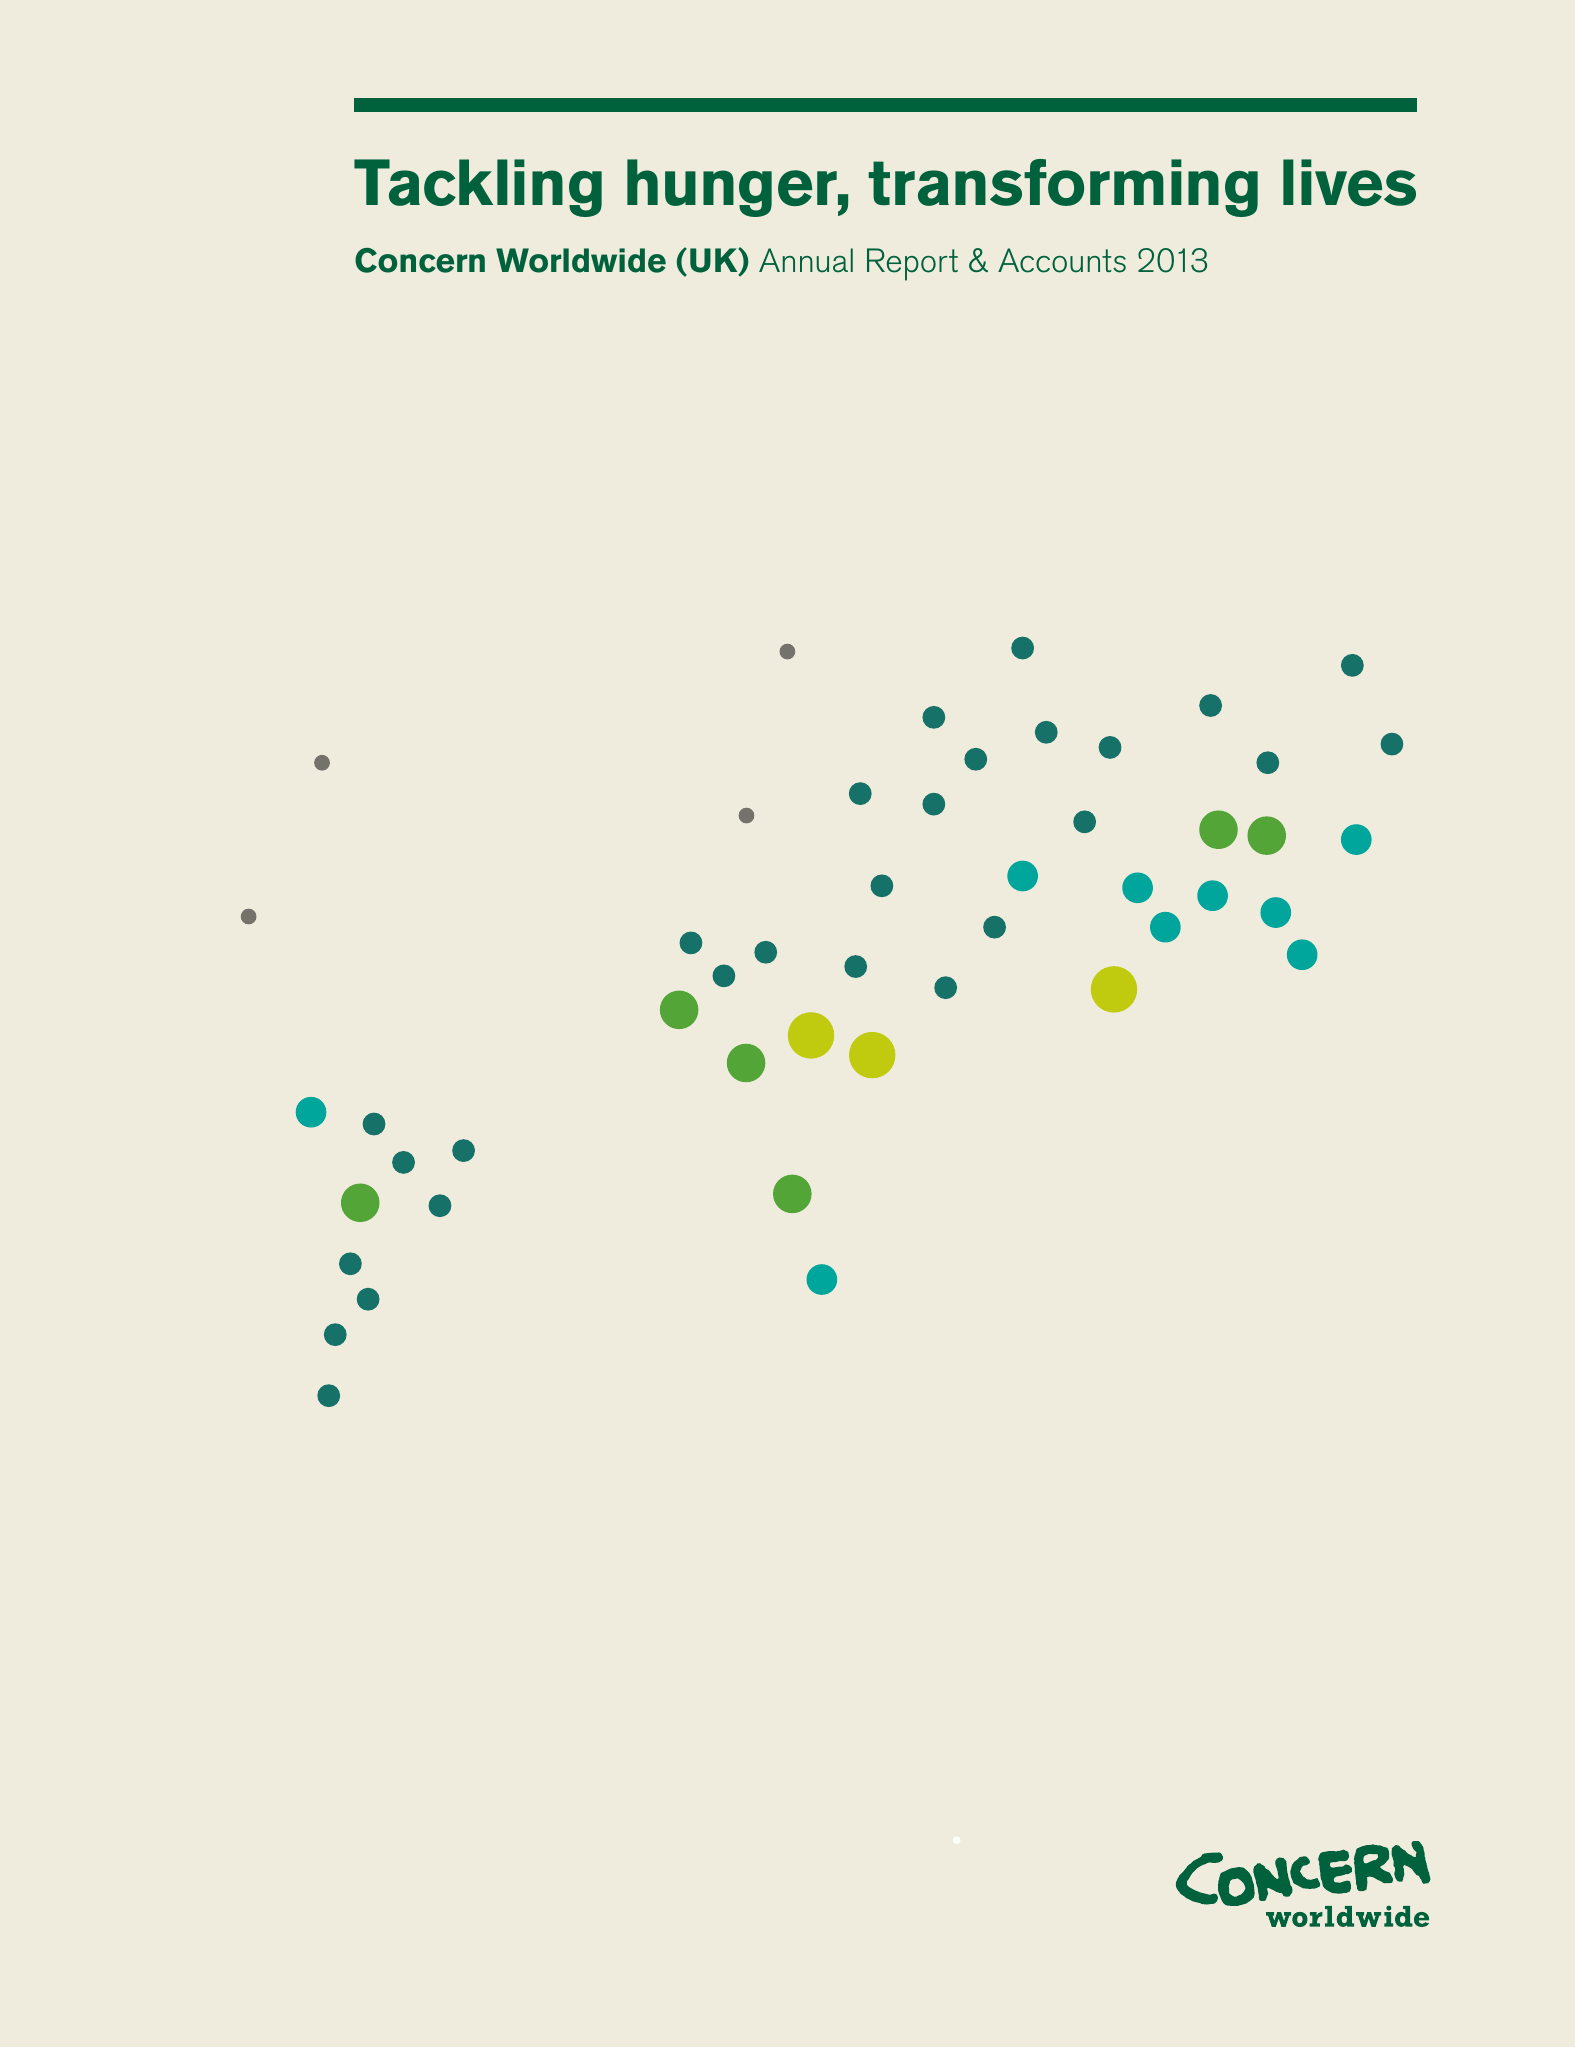What is the value for the charity_name?
Answer the question using a single word or phrase. Concern Worldwide (Uk) 